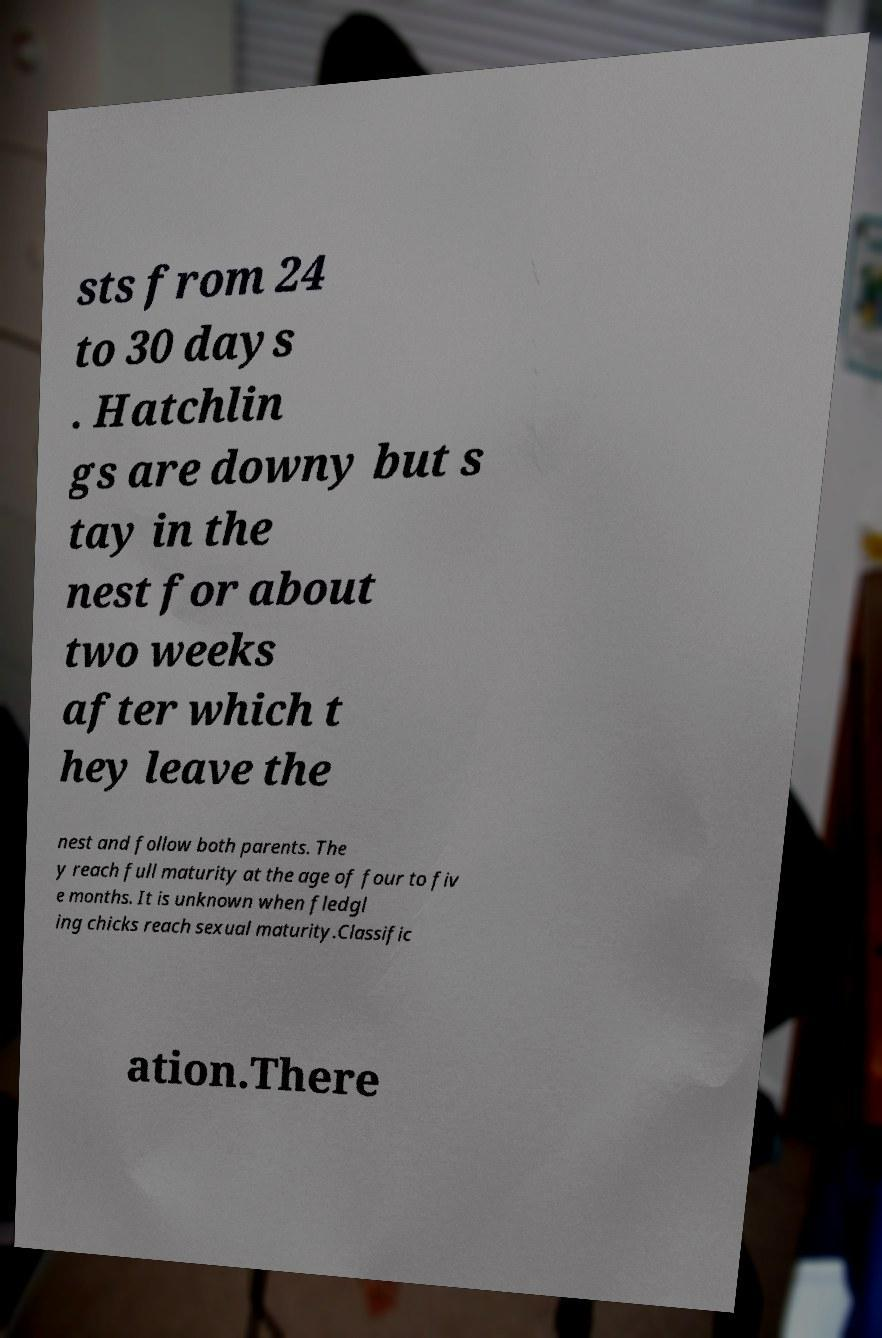There's text embedded in this image that I need extracted. Can you transcribe it verbatim? sts from 24 to 30 days . Hatchlin gs are downy but s tay in the nest for about two weeks after which t hey leave the nest and follow both parents. The y reach full maturity at the age of four to fiv e months. It is unknown when fledgl ing chicks reach sexual maturity.Classific ation.There 